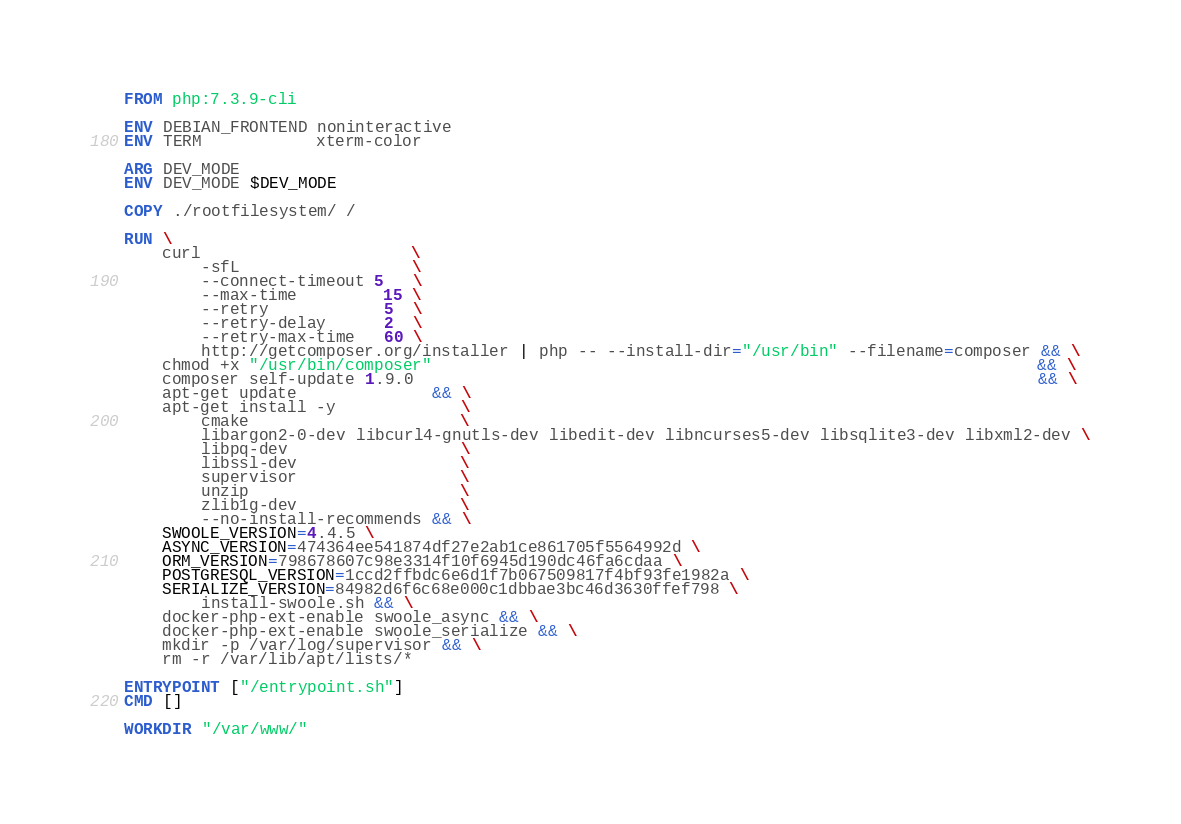Convert code to text. <code><loc_0><loc_0><loc_500><loc_500><_Dockerfile_>FROM php:7.3.9-cli

ENV DEBIAN_FRONTEND noninteractive
ENV TERM            xterm-color

ARG DEV_MODE
ENV DEV_MODE $DEV_MODE

COPY ./rootfilesystem/ /

RUN \
    curl                      \
        -sfL                  \
        --connect-timeout 5   \
        --max-time         15 \
        --retry            5  \
        --retry-delay      2  \
        --retry-max-time   60 \
        http://getcomposer.org/installer | php -- --install-dir="/usr/bin" --filename=composer && \
    chmod +x "/usr/bin/composer"                                                               && \
    composer self-update 1.9.0                                                                 && \
    apt-get update              && \
    apt-get install -y             \
        cmake                      \
        libargon2-0-dev libcurl4-gnutls-dev libedit-dev libncurses5-dev libsqlite3-dev libxml2-dev \
        libpq-dev                  \
        libssl-dev                 \
        supervisor                 \
        unzip                      \
        zlib1g-dev                 \
        --no-install-recommends && \
    SWOOLE_VERSION=4.4.5 \
    ASYNC_VERSION=474364ee541874df27e2ab1ce861705f5564992d \
    ORM_VERSION=798678607c98e3314f10f6945d190dc46fa6cdaa \
    POSTGRESQL_VERSION=1ccd2ffbdc6e6d1f7b067509817f4bf93fe1982a \
    SERIALIZE_VERSION=84982d6f6c68e000c1dbbae3bc46d3630ffef798 \
        install-swoole.sh && \
    docker-php-ext-enable swoole_async && \
    docker-php-ext-enable swoole_serialize && \
    mkdir -p /var/log/supervisor && \
    rm -r /var/lib/apt/lists/*

ENTRYPOINT ["/entrypoint.sh"]
CMD []

WORKDIR "/var/www/"
</code> 